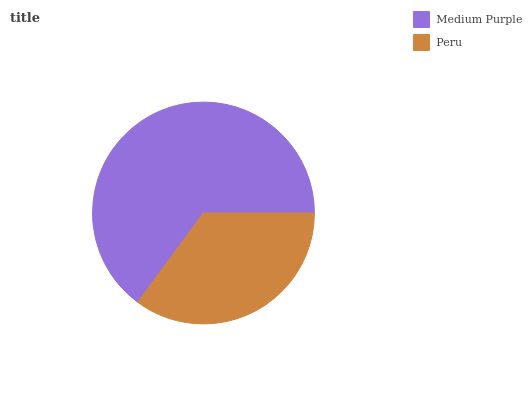Is Peru the minimum?
Answer yes or no. Yes. Is Medium Purple the maximum?
Answer yes or no. Yes. Is Peru the maximum?
Answer yes or no. No. Is Medium Purple greater than Peru?
Answer yes or no. Yes. Is Peru less than Medium Purple?
Answer yes or no. Yes. Is Peru greater than Medium Purple?
Answer yes or no. No. Is Medium Purple less than Peru?
Answer yes or no. No. Is Medium Purple the high median?
Answer yes or no. Yes. Is Peru the low median?
Answer yes or no. Yes. Is Peru the high median?
Answer yes or no. No. Is Medium Purple the low median?
Answer yes or no. No. 